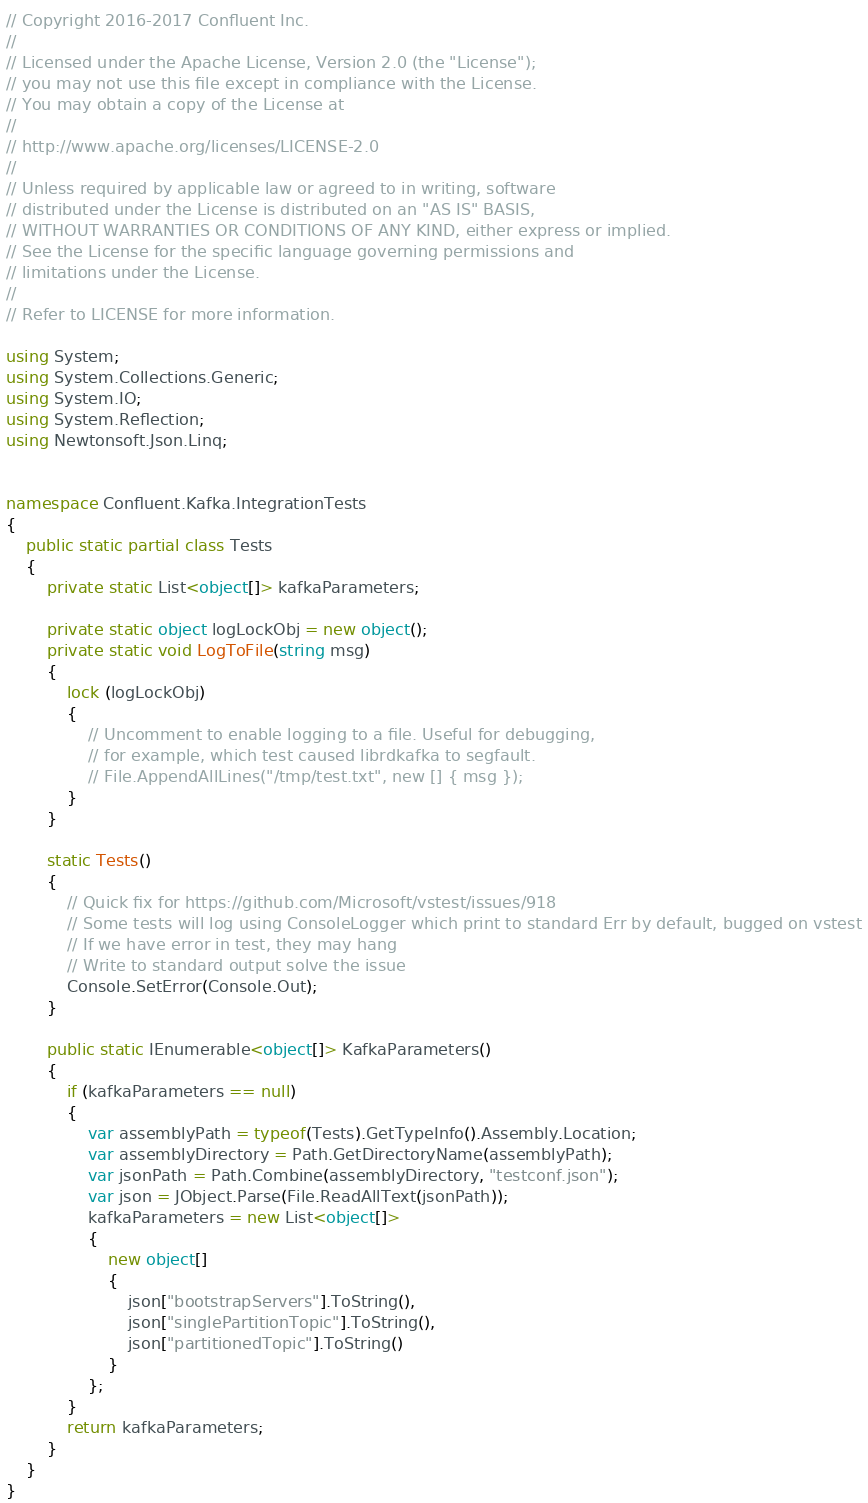<code> <loc_0><loc_0><loc_500><loc_500><_C#_>// Copyright 2016-2017 Confluent Inc.
//
// Licensed under the Apache License, Version 2.0 (the "License");
// you may not use this file except in compliance with the License.
// You may obtain a copy of the License at
//
// http://www.apache.org/licenses/LICENSE-2.0
//
// Unless required by applicable law or agreed to in writing, software
// distributed under the License is distributed on an "AS IS" BASIS,
// WITHOUT WARRANTIES OR CONDITIONS OF ANY KIND, either express or implied.
// See the License for the specific language governing permissions and
// limitations under the License.
//
// Refer to LICENSE for more information.

using System;
using System.Collections.Generic;
using System.IO;
using System.Reflection;
using Newtonsoft.Json.Linq;


namespace Confluent.Kafka.IntegrationTests
{
    public static partial class Tests
    {
        private static List<object[]> kafkaParameters;

        private static object logLockObj = new object();
        private static void LogToFile(string msg)
        {
            lock (logLockObj)
            {
                // Uncomment to enable logging to a file. Useful for debugging,
                // for example, which test caused librdkafka to segfault.
                // File.AppendAllLines("/tmp/test.txt", new [] { msg });
            }
        }

        static Tests()
        {
            // Quick fix for https://github.com/Microsoft/vstest/issues/918
            // Some tests will log using ConsoleLogger which print to standard Err by default, bugged on vstest
            // If we have error in test, they may hang
            // Write to standard output solve the issue
            Console.SetError(Console.Out);
        }

        public static IEnumerable<object[]> KafkaParameters()
        {
            if (kafkaParameters == null)
            {
                var assemblyPath = typeof(Tests).GetTypeInfo().Assembly.Location;
                var assemblyDirectory = Path.GetDirectoryName(assemblyPath);
                var jsonPath = Path.Combine(assemblyDirectory, "testconf.json");
                var json = JObject.Parse(File.ReadAllText(jsonPath));
                kafkaParameters = new List<object[]>
                {
                    new object[]
                    {
                        json["bootstrapServers"].ToString(),
                        json["singlePartitionTopic"].ToString(),
                        json["partitionedTopic"].ToString()
                    }
                };
            }
            return kafkaParameters;
        }
    }
}
</code> 